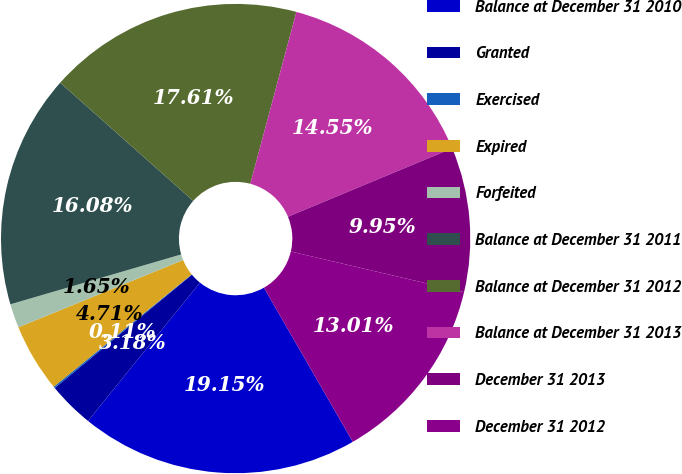Convert chart to OTSL. <chart><loc_0><loc_0><loc_500><loc_500><pie_chart><fcel>Balance at December 31 2010<fcel>Granted<fcel>Exercised<fcel>Expired<fcel>Forfeited<fcel>Balance at December 31 2011<fcel>Balance at December 31 2012<fcel>Balance at December 31 2013<fcel>December 31 2013<fcel>December 31 2012<nl><fcel>19.15%<fcel>3.18%<fcel>0.11%<fcel>4.71%<fcel>1.65%<fcel>16.08%<fcel>17.61%<fcel>14.55%<fcel>9.95%<fcel>13.01%<nl></chart> 